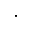<formula> <loc_0><loc_0><loc_500><loc_500>.</formula> 